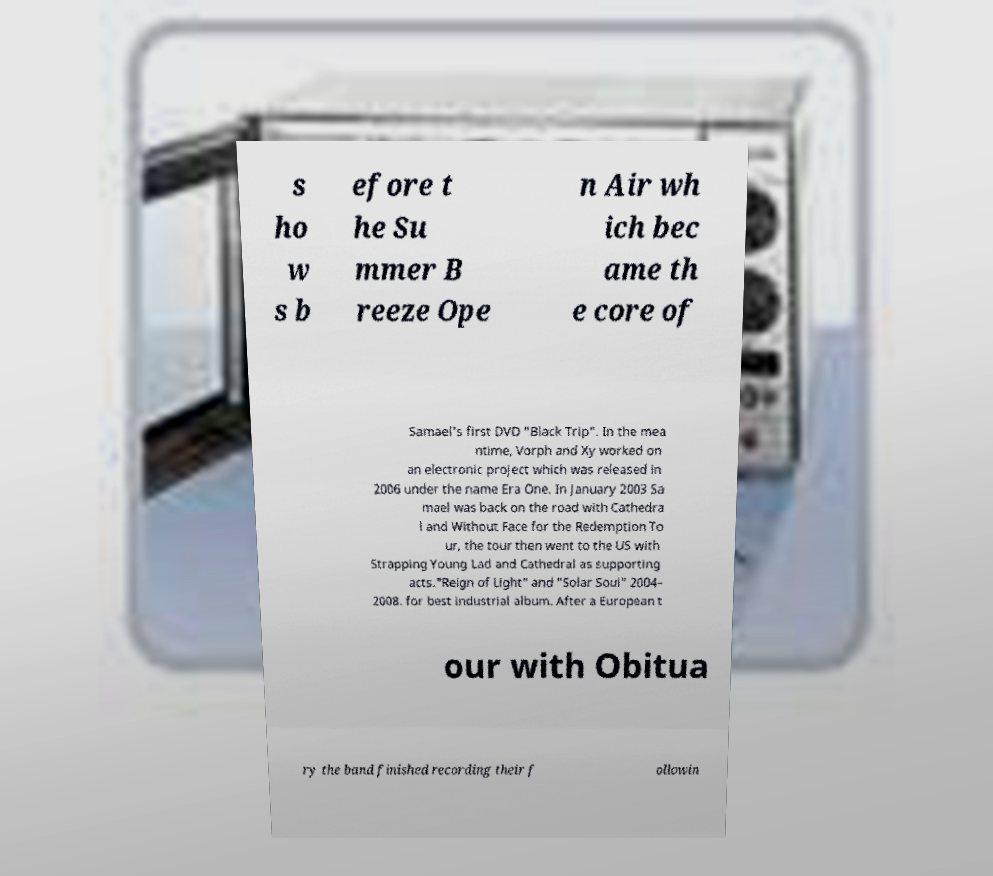There's text embedded in this image that I need extracted. Can you transcribe it verbatim? s ho w s b efore t he Su mmer B reeze Ope n Air wh ich bec ame th e core of Samael's first DVD "Black Trip". In the mea ntime, Vorph and Xy worked on an electronic project which was released in 2006 under the name Era One. In January 2003 Sa mael was back on the road with Cathedra l and Without Face for the Redemption To ur, the tour then went to the US with Strapping Young Lad and Cathedral as supporting acts."Reign of Light" and "Solar Soul" 2004– 2008. for best industrial album. After a European t our with Obitua ry the band finished recording their f ollowin 